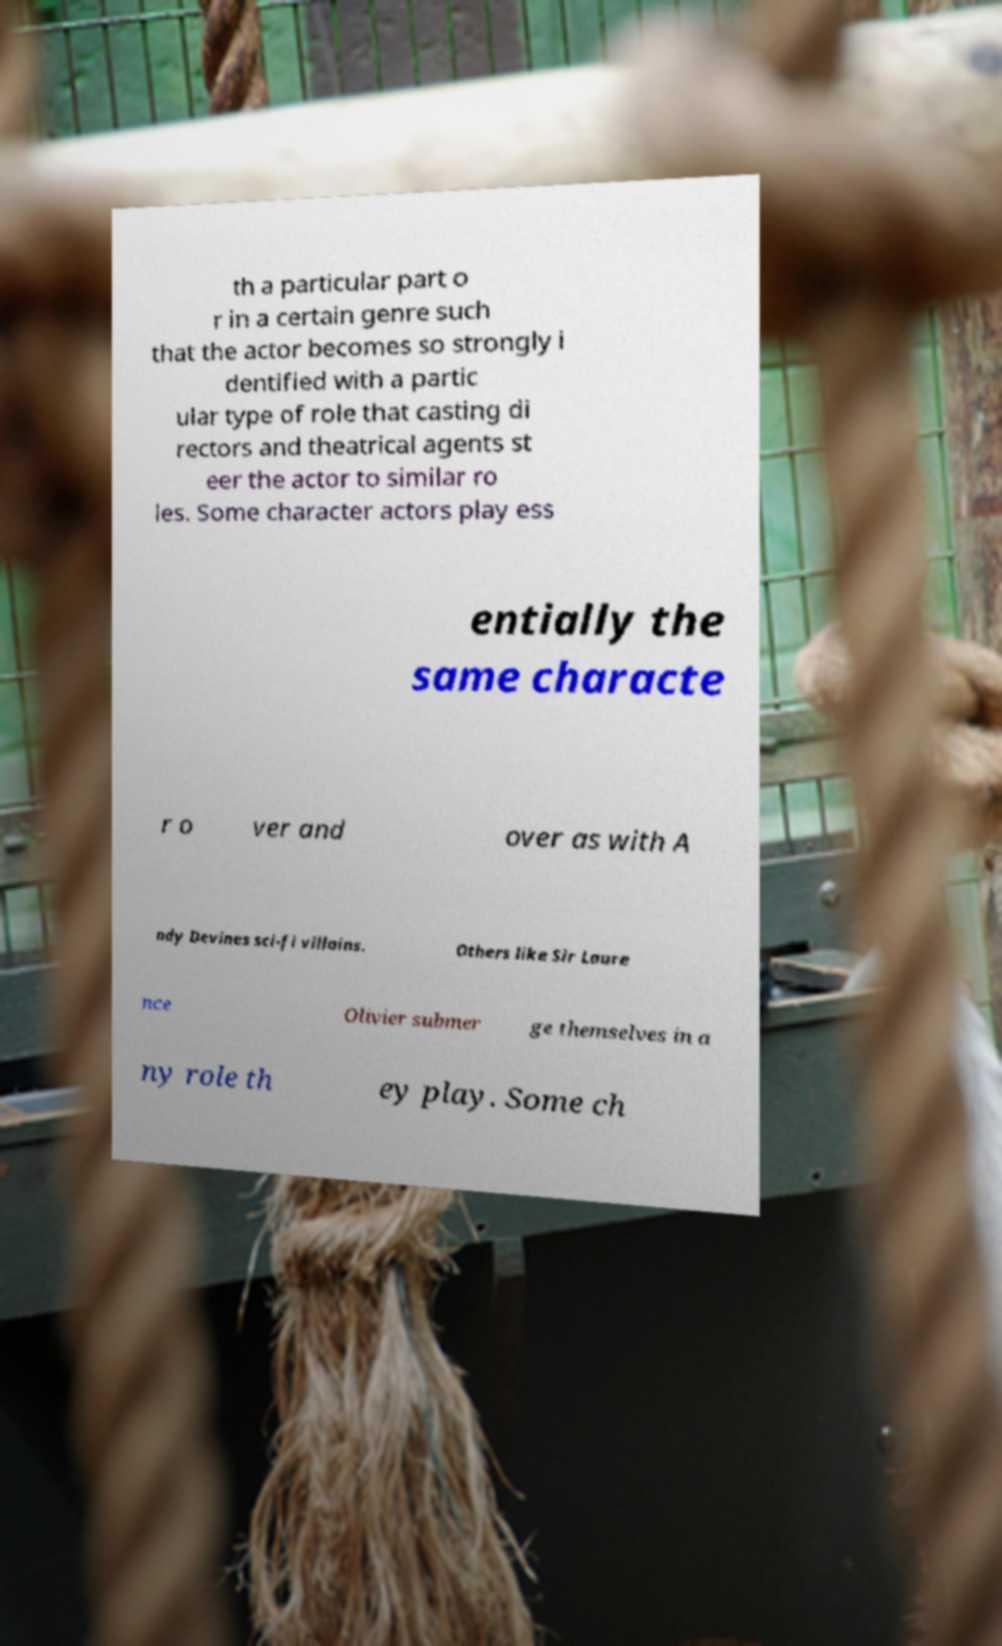Can you read and provide the text displayed in the image?This photo seems to have some interesting text. Can you extract and type it out for me? th a particular part o r in a certain genre such that the actor becomes so strongly i dentified with a partic ular type of role that casting di rectors and theatrical agents st eer the actor to similar ro les. Some character actors play ess entially the same characte r o ver and over as with A ndy Devines sci-fi villains. Others like Sir Laure nce Olivier submer ge themselves in a ny role th ey play. Some ch 